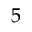Convert formula to latex. <formula><loc_0><loc_0><loc_500><loc_500>5</formula> 